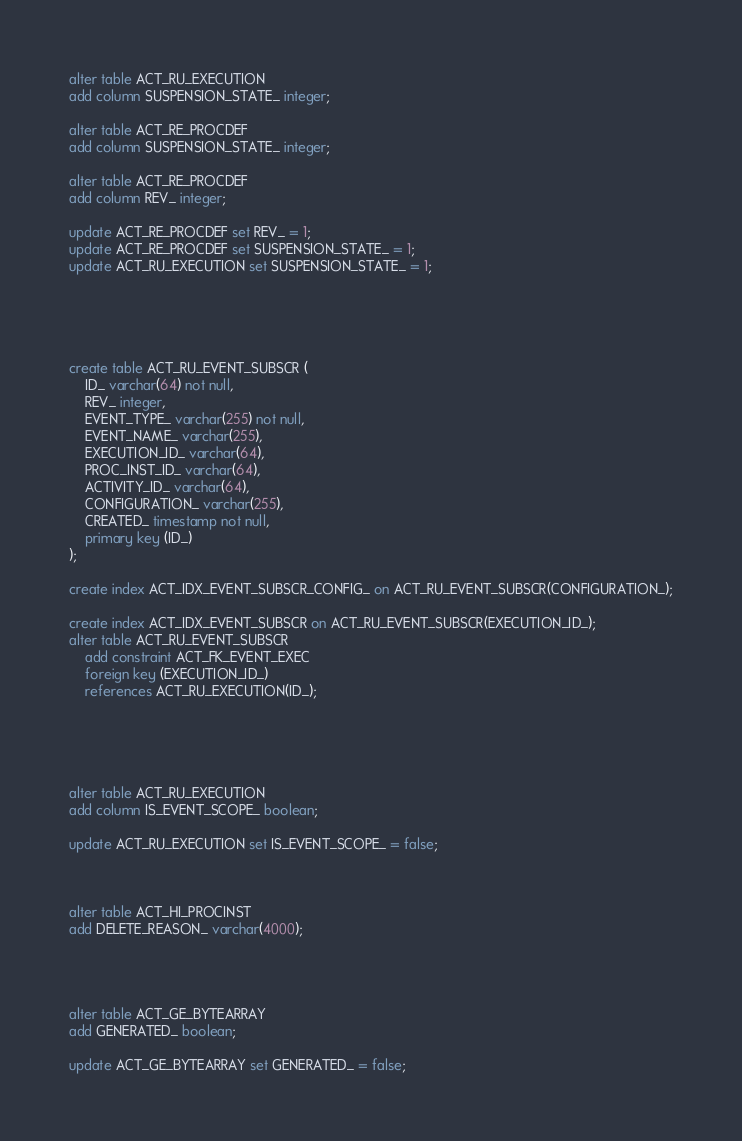Convert code to text. <code><loc_0><loc_0><loc_500><loc_500><_SQL_>alter table ACT_RU_EXECUTION 
add column SUSPENSION_STATE_ integer;

alter table ACT_RE_PROCDEF
add column SUSPENSION_STATE_ integer;

alter table ACT_RE_PROCDEF
add column REV_ integer;

update ACT_RE_PROCDEF set REV_ = 1;
update ACT_RE_PROCDEF set SUSPENSION_STATE_ = 1;
update ACT_RU_EXECUTION set SUSPENSION_STATE_ = 1;





create table ACT_RU_EVENT_SUBSCR (
    ID_ varchar(64) not null,
    REV_ integer,
    EVENT_TYPE_ varchar(255) not null,
    EVENT_NAME_ varchar(255),
    EXECUTION_ID_ varchar(64),
    PROC_INST_ID_ varchar(64),
    ACTIVITY_ID_ varchar(64),
    CONFIGURATION_ varchar(255),
    CREATED_ timestamp not null,
    primary key (ID_)
);

create index ACT_IDX_EVENT_SUBSCR_CONFIG_ on ACT_RU_EVENT_SUBSCR(CONFIGURATION_);

create index ACT_IDX_EVENT_SUBSCR on ACT_RU_EVENT_SUBSCR(EXECUTION_ID_);
alter table ACT_RU_EVENT_SUBSCR
    add constraint ACT_FK_EVENT_EXEC
    foreign key (EXECUTION_ID_)
    references ACT_RU_EXECUTION(ID_);
    
    
    
    
    
alter table ACT_RU_EXECUTION 
add column IS_EVENT_SCOPE_ boolean;

update ACT_RU_EXECUTION set IS_EVENT_SCOPE_ = false;



alter table ACT_HI_PROCINST
add DELETE_REASON_ varchar(4000);




alter table ACT_GE_BYTEARRAY 
add GENERATED_ boolean;

update ACT_GE_BYTEARRAY set GENERATED_ = false;
</code> 